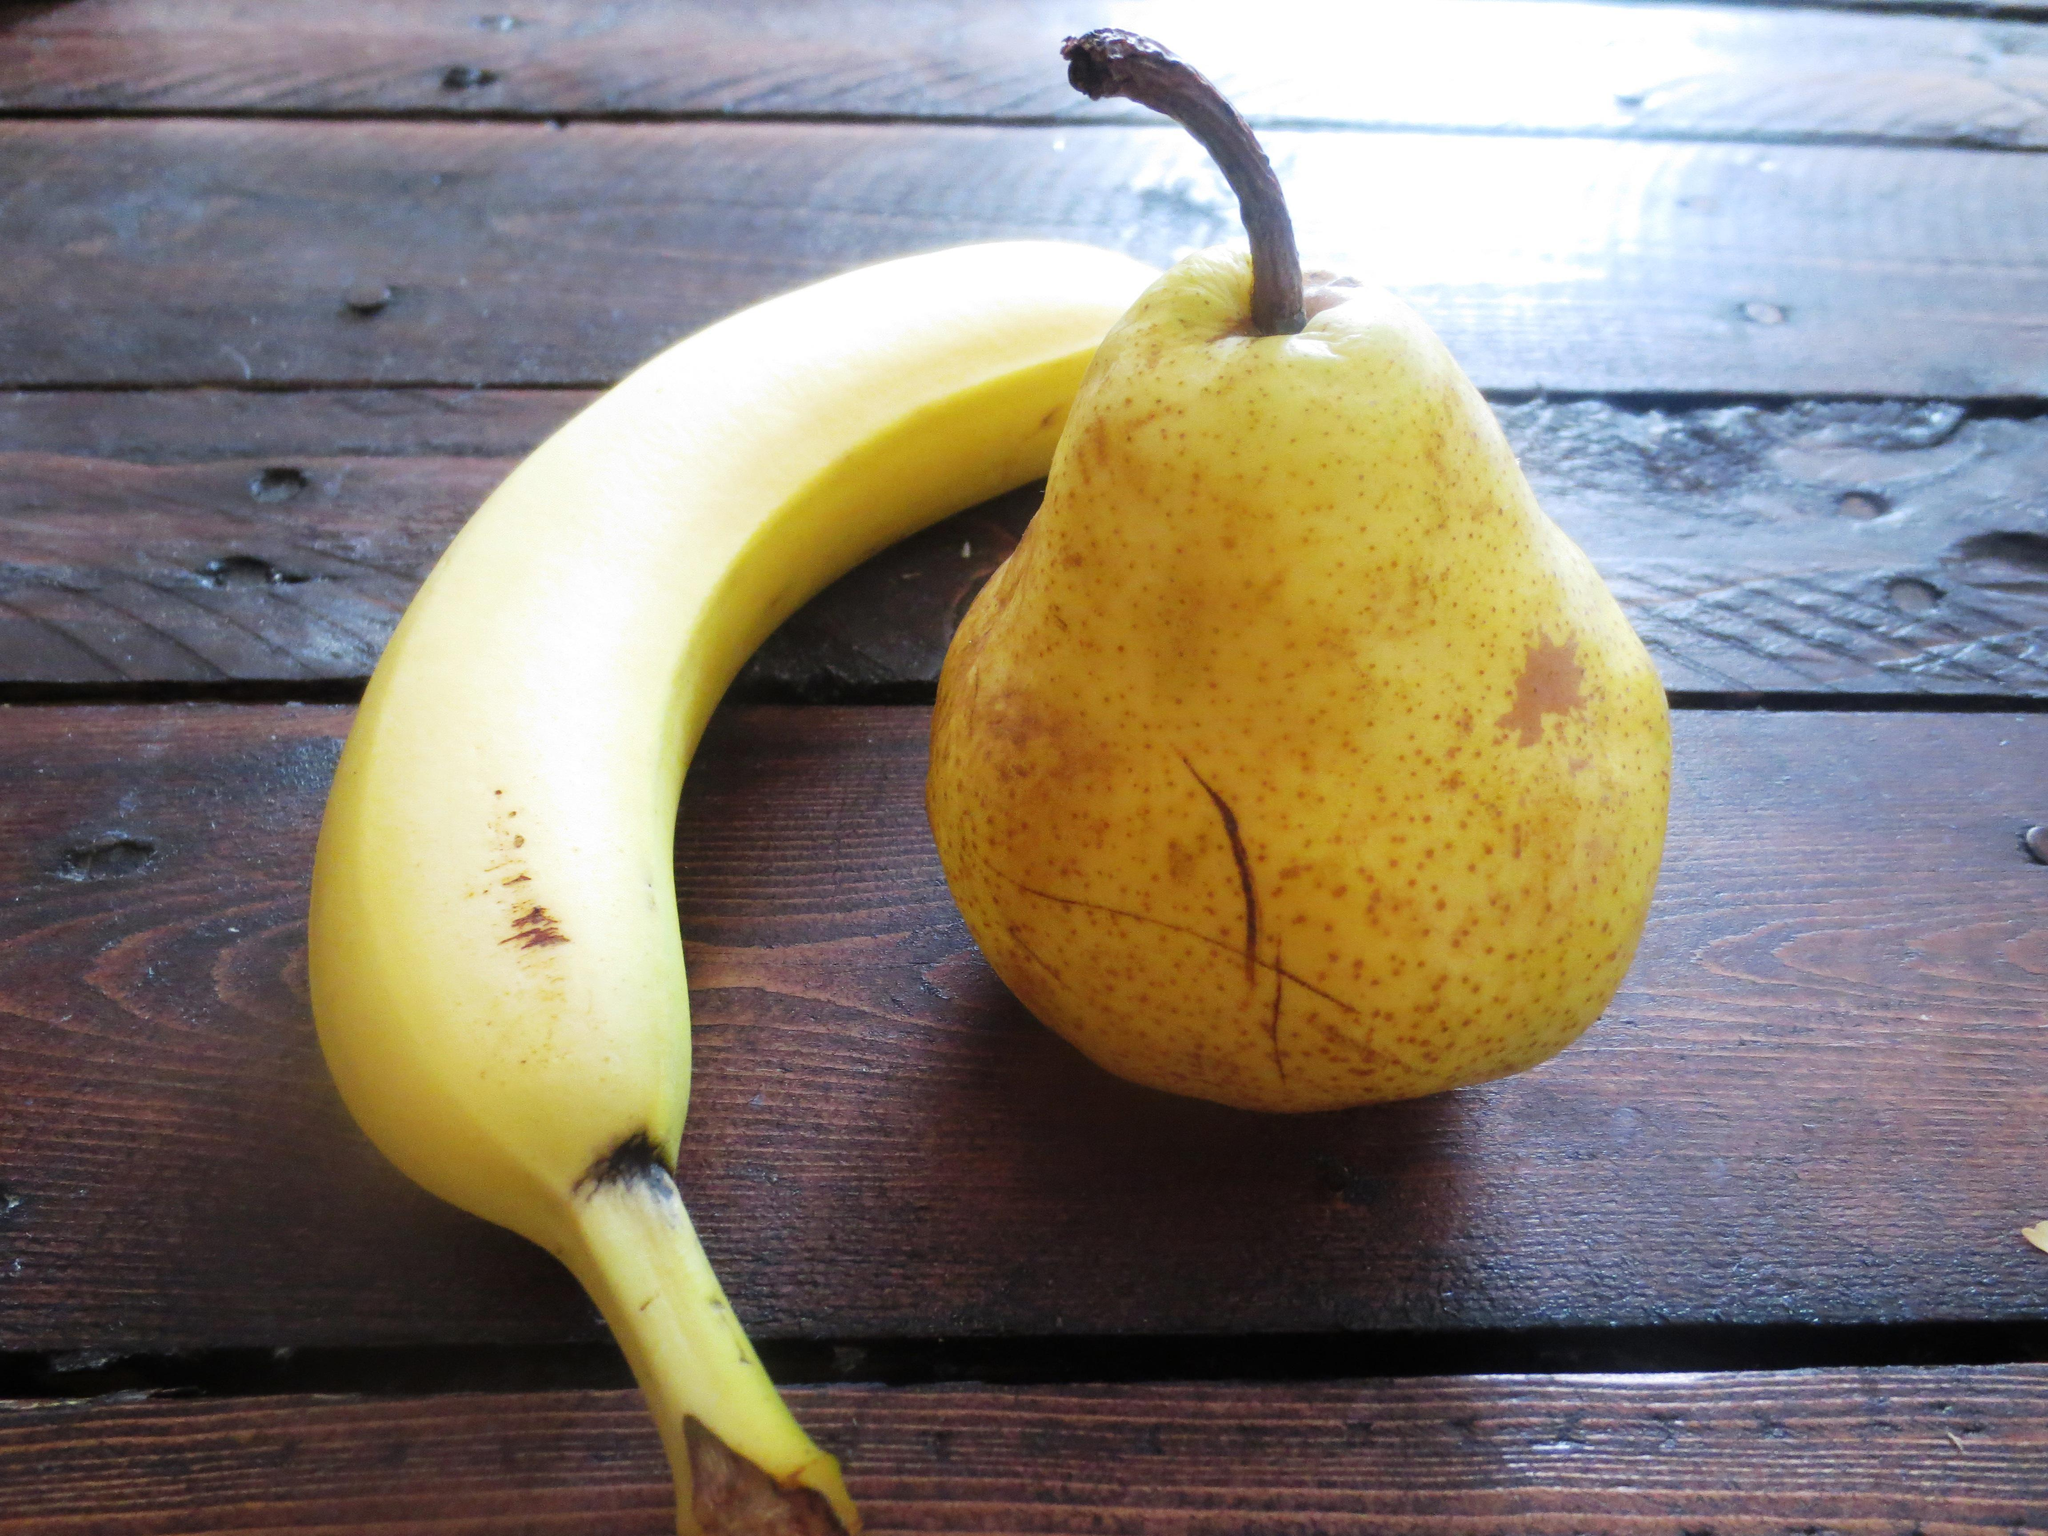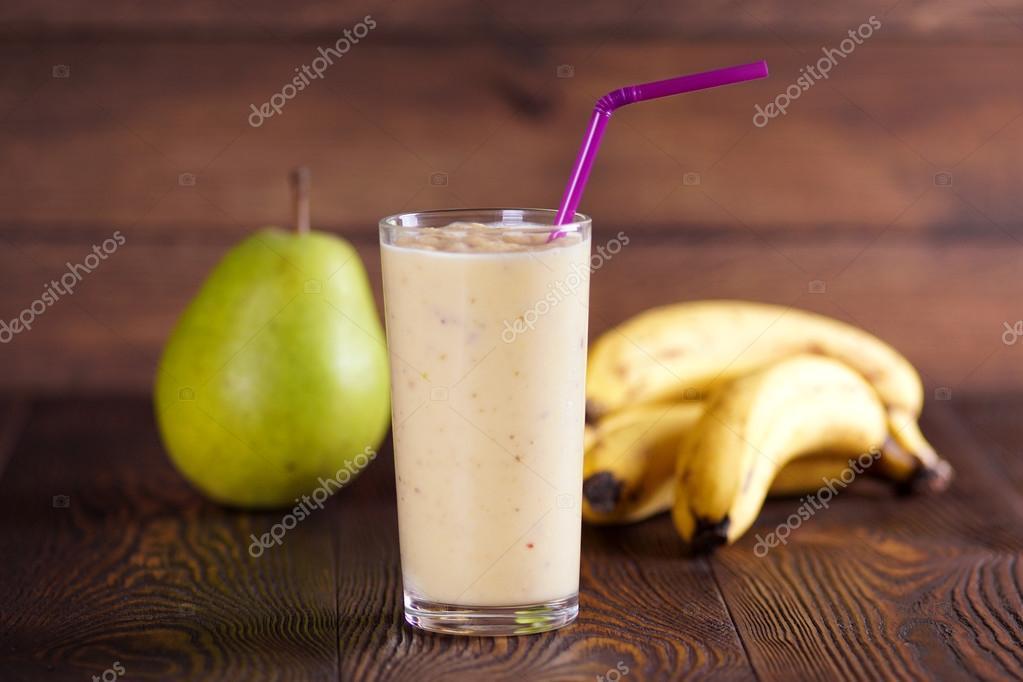The first image is the image on the left, the second image is the image on the right. Given the left and right images, does the statement "In one image, a glass of breakfast drink with a  straw is in front of whole bananas and at least one pear." hold true? Answer yes or no. Yes. The first image is the image on the left, the second image is the image on the right. Analyze the images presented: Is the assertion "An image shows intact banana, pear and beverage." valid? Answer yes or no. Yes. 